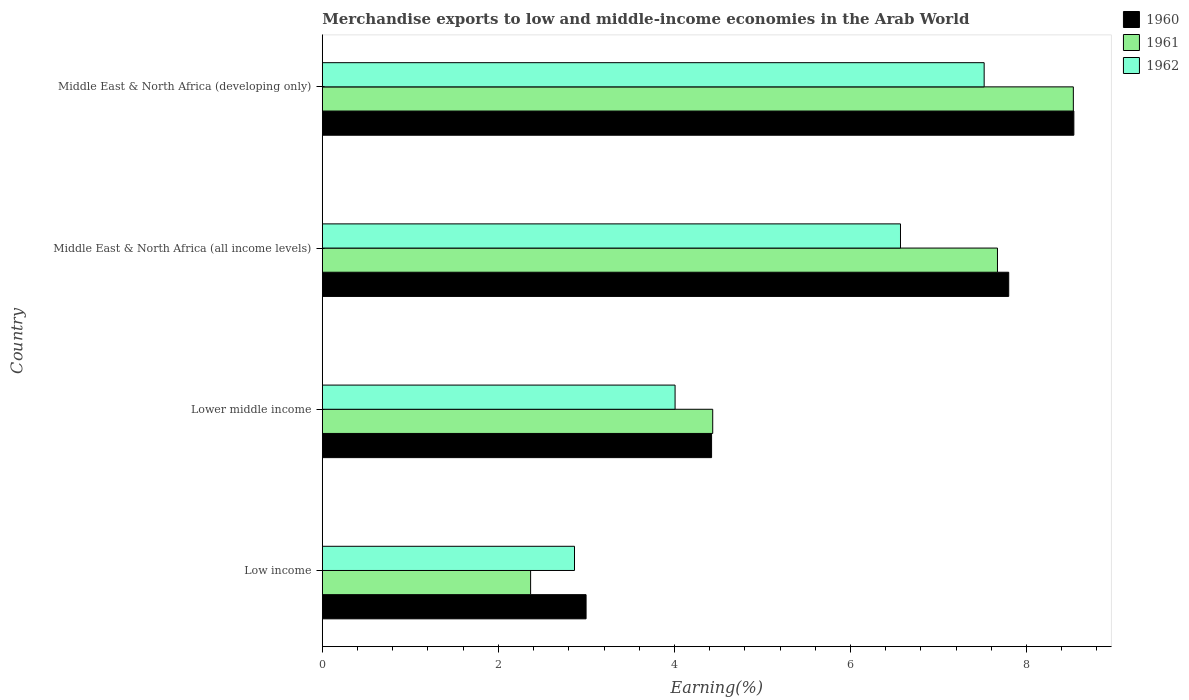Are the number of bars on each tick of the Y-axis equal?
Offer a very short reply. Yes. How many bars are there on the 3rd tick from the top?
Ensure brevity in your answer.  3. How many bars are there on the 1st tick from the bottom?
Provide a succinct answer. 3. What is the label of the 2nd group of bars from the top?
Ensure brevity in your answer.  Middle East & North Africa (all income levels). In how many cases, is the number of bars for a given country not equal to the number of legend labels?
Provide a short and direct response. 0. What is the percentage of amount earned from merchandise exports in 1960 in Low income?
Give a very brief answer. 3. Across all countries, what is the maximum percentage of amount earned from merchandise exports in 1960?
Your answer should be compact. 8.54. Across all countries, what is the minimum percentage of amount earned from merchandise exports in 1962?
Your answer should be very brief. 2.86. In which country was the percentage of amount earned from merchandise exports in 1960 maximum?
Offer a terse response. Middle East & North Africa (developing only). What is the total percentage of amount earned from merchandise exports in 1960 in the graph?
Offer a very short reply. 23.75. What is the difference between the percentage of amount earned from merchandise exports in 1961 in Low income and that in Lower middle income?
Provide a short and direct response. -2.07. What is the difference between the percentage of amount earned from merchandise exports in 1962 in Middle East & North Africa (developing only) and the percentage of amount earned from merchandise exports in 1961 in Low income?
Your answer should be compact. 5.15. What is the average percentage of amount earned from merchandise exports in 1960 per country?
Ensure brevity in your answer.  5.94. What is the difference between the percentage of amount earned from merchandise exports in 1960 and percentage of amount earned from merchandise exports in 1961 in Middle East & North Africa (all income levels)?
Provide a short and direct response. 0.13. In how many countries, is the percentage of amount earned from merchandise exports in 1960 greater than 3.6 %?
Offer a very short reply. 3. What is the ratio of the percentage of amount earned from merchandise exports in 1961 in Lower middle income to that in Middle East & North Africa (all income levels)?
Give a very brief answer. 0.58. What is the difference between the highest and the second highest percentage of amount earned from merchandise exports in 1962?
Your response must be concise. 0.95. What is the difference between the highest and the lowest percentage of amount earned from merchandise exports in 1961?
Make the answer very short. 6.17. Is the sum of the percentage of amount earned from merchandise exports in 1960 in Low income and Lower middle income greater than the maximum percentage of amount earned from merchandise exports in 1962 across all countries?
Your answer should be very brief. No. What does the 1st bar from the bottom in Middle East & North Africa (all income levels) represents?
Ensure brevity in your answer.  1960. How many bars are there?
Your answer should be very brief. 12. Are the values on the major ticks of X-axis written in scientific E-notation?
Provide a succinct answer. No. How many legend labels are there?
Your answer should be very brief. 3. How are the legend labels stacked?
Your answer should be compact. Vertical. What is the title of the graph?
Your response must be concise. Merchandise exports to low and middle-income economies in the Arab World. Does "1974" appear as one of the legend labels in the graph?
Your answer should be very brief. No. What is the label or title of the X-axis?
Your answer should be very brief. Earning(%). What is the Earning(%) in 1960 in Low income?
Your answer should be very brief. 3. What is the Earning(%) of 1961 in Low income?
Provide a succinct answer. 2.37. What is the Earning(%) of 1962 in Low income?
Keep it short and to the point. 2.86. What is the Earning(%) in 1960 in Lower middle income?
Your answer should be compact. 4.42. What is the Earning(%) of 1961 in Lower middle income?
Offer a terse response. 4.43. What is the Earning(%) of 1962 in Lower middle income?
Offer a terse response. 4.01. What is the Earning(%) of 1960 in Middle East & North Africa (all income levels)?
Your answer should be compact. 7.8. What is the Earning(%) of 1961 in Middle East & North Africa (all income levels)?
Ensure brevity in your answer.  7.67. What is the Earning(%) in 1962 in Middle East & North Africa (all income levels)?
Your answer should be compact. 6.57. What is the Earning(%) of 1960 in Middle East & North Africa (developing only)?
Your answer should be very brief. 8.54. What is the Earning(%) in 1961 in Middle East & North Africa (developing only)?
Your answer should be compact. 8.53. What is the Earning(%) in 1962 in Middle East & North Africa (developing only)?
Offer a terse response. 7.52. Across all countries, what is the maximum Earning(%) of 1960?
Make the answer very short. 8.54. Across all countries, what is the maximum Earning(%) in 1961?
Offer a very short reply. 8.53. Across all countries, what is the maximum Earning(%) in 1962?
Offer a very short reply. 7.52. Across all countries, what is the minimum Earning(%) in 1960?
Provide a succinct answer. 3. Across all countries, what is the minimum Earning(%) of 1961?
Provide a succinct answer. 2.37. Across all countries, what is the minimum Earning(%) of 1962?
Your answer should be compact. 2.86. What is the total Earning(%) in 1960 in the graph?
Provide a short and direct response. 23.75. What is the total Earning(%) in 1961 in the graph?
Offer a terse response. 23. What is the total Earning(%) of 1962 in the graph?
Offer a terse response. 20.96. What is the difference between the Earning(%) in 1960 in Low income and that in Lower middle income?
Your response must be concise. -1.43. What is the difference between the Earning(%) in 1961 in Low income and that in Lower middle income?
Make the answer very short. -2.07. What is the difference between the Earning(%) in 1962 in Low income and that in Lower middle income?
Your response must be concise. -1.14. What is the difference between the Earning(%) of 1960 in Low income and that in Middle East & North Africa (all income levels)?
Provide a short and direct response. -4.8. What is the difference between the Earning(%) of 1961 in Low income and that in Middle East & North Africa (all income levels)?
Make the answer very short. -5.3. What is the difference between the Earning(%) in 1962 in Low income and that in Middle East & North Africa (all income levels)?
Provide a short and direct response. -3.7. What is the difference between the Earning(%) of 1960 in Low income and that in Middle East & North Africa (developing only)?
Make the answer very short. -5.54. What is the difference between the Earning(%) in 1961 in Low income and that in Middle East & North Africa (developing only)?
Your answer should be compact. -6.17. What is the difference between the Earning(%) in 1962 in Low income and that in Middle East & North Africa (developing only)?
Provide a succinct answer. -4.65. What is the difference between the Earning(%) of 1960 in Lower middle income and that in Middle East & North Africa (all income levels)?
Make the answer very short. -3.38. What is the difference between the Earning(%) in 1961 in Lower middle income and that in Middle East & North Africa (all income levels)?
Your answer should be compact. -3.23. What is the difference between the Earning(%) of 1962 in Lower middle income and that in Middle East & North Africa (all income levels)?
Provide a succinct answer. -2.56. What is the difference between the Earning(%) of 1960 in Lower middle income and that in Middle East & North Africa (developing only)?
Your answer should be compact. -4.12. What is the difference between the Earning(%) of 1961 in Lower middle income and that in Middle East & North Africa (developing only)?
Ensure brevity in your answer.  -4.1. What is the difference between the Earning(%) of 1962 in Lower middle income and that in Middle East & North Africa (developing only)?
Your answer should be very brief. -3.51. What is the difference between the Earning(%) of 1960 in Middle East & North Africa (all income levels) and that in Middle East & North Africa (developing only)?
Give a very brief answer. -0.74. What is the difference between the Earning(%) in 1961 in Middle East & North Africa (all income levels) and that in Middle East & North Africa (developing only)?
Make the answer very short. -0.86. What is the difference between the Earning(%) of 1962 in Middle East & North Africa (all income levels) and that in Middle East & North Africa (developing only)?
Give a very brief answer. -0.95. What is the difference between the Earning(%) in 1960 in Low income and the Earning(%) in 1961 in Lower middle income?
Offer a very short reply. -1.44. What is the difference between the Earning(%) in 1960 in Low income and the Earning(%) in 1962 in Lower middle income?
Your response must be concise. -1.01. What is the difference between the Earning(%) in 1961 in Low income and the Earning(%) in 1962 in Lower middle income?
Give a very brief answer. -1.64. What is the difference between the Earning(%) of 1960 in Low income and the Earning(%) of 1961 in Middle East & North Africa (all income levels)?
Provide a succinct answer. -4.67. What is the difference between the Earning(%) of 1960 in Low income and the Earning(%) of 1962 in Middle East & North Africa (all income levels)?
Make the answer very short. -3.57. What is the difference between the Earning(%) in 1961 in Low income and the Earning(%) in 1962 in Middle East & North Africa (all income levels)?
Ensure brevity in your answer.  -4.2. What is the difference between the Earning(%) in 1960 in Low income and the Earning(%) in 1961 in Middle East & North Africa (developing only)?
Your answer should be very brief. -5.54. What is the difference between the Earning(%) of 1960 in Low income and the Earning(%) of 1962 in Middle East & North Africa (developing only)?
Your answer should be very brief. -4.52. What is the difference between the Earning(%) of 1961 in Low income and the Earning(%) of 1962 in Middle East & North Africa (developing only)?
Your answer should be compact. -5.15. What is the difference between the Earning(%) in 1960 in Lower middle income and the Earning(%) in 1961 in Middle East & North Africa (all income levels)?
Your answer should be compact. -3.25. What is the difference between the Earning(%) in 1960 in Lower middle income and the Earning(%) in 1962 in Middle East & North Africa (all income levels)?
Offer a terse response. -2.15. What is the difference between the Earning(%) of 1961 in Lower middle income and the Earning(%) of 1962 in Middle East & North Africa (all income levels)?
Your response must be concise. -2.13. What is the difference between the Earning(%) in 1960 in Lower middle income and the Earning(%) in 1961 in Middle East & North Africa (developing only)?
Offer a very short reply. -4.11. What is the difference between the Earning(%) of 1960 in Lower middle income and the Earning(%) of 1962 in Middle East & North Africa (developing only)?
Keep it short and to the point. -3.1. What is the difference between the Earning(%) in 1961 in Lower middle income and the Earning(%) in 1962 in Middle East & North Africa (developing only)?
Your response must be concise. -3.08. What is the difference between the Earning(%) in 1960 in Middle East & North Africa (all income levels) and the Earning(%) in 1961 in Middle East & North Africa (developing only)?
Give a very brief answer. -0.73. What is the difference between the Earning(%) in 1960 in Middle East & North Africa (all income levels) and the Earning(%) in 1962 in Middle East & North Africa (developing only)?
Your response must be concise. 0.28. What is the difference between the Earning(%) in 1961 in Middle East & North Africa (all income levels) and the Earning(%) in 1962 in Middle East & North Africa (developing only)?
Provide a succinct answer. 0.15. What is the average Earning(%) of 1960 per country?
Make the answer very short. 5.94. What is the average Earning(%) in 1961 per country?
Provide a succinct answer. 5.75. What is the average Earning(%) in 1962 per country?
Give a very brief answer. 5.24. What is the difference between the Earning(%) of 1960 and Earning(%) of 1961 in Low income?
Provide a short and direct response. 0.63. What is the difference between the Earning(%) of 1960 and Earning(%) of 1962 in Low income?
Offer a very short reply. 0.13. What is the difference between the Earning(%) of 1961 and Earning(%) of 1962 in Low income?
Offer a terse response. -0.5. What is the difference between the Earning(%) of 1960 and Earning(%) of 1961 in Lower middle income?
Provide a short and direct response. -0.01. What is the difference between the Earning(%) of 1960 and Earning(%) of 1962 in Lower middle income?
Provide a short and direct response. 0.41. What is the difference between the Earning(%) of 1961 and Earning(%) of 1962 in Lower middle income?
Your answer should be compact. 0.43. What is the difference between the Earning(%) in 1960 and Earning(%) in 1961 in Middle East & North Africa (all income levels)?
Provide a short and direct response. 0.13. What is the difference between the Earning(%) of 1960 and Earning(%) of 1962 in Middle East & North Africa (all income levels)?
Provide a short and direct response. 1.23. What is the difference between the Earning(%) of 1961 and Earning(%) of 1962 in Middle East & North Africa (all income levels)?
Offer a very short reply. 1.1. What is the difference between the Earning(%) of 1960 and Earning(%) of 1961 in Middle East & North Africa (developing only)?
Make the answer very short. 0.01. What is the difference between the Earning(%) of 1960 and Earning(%) of 1962 in Middle East & North Africa (developing only)?
Provide a short and direct response. 1.02. What is the difference between the Earning(%) in 1961 and Earning(%) in 1962 in Middle East & North Africa (developing only)?
Provide a succinct answer. 1.01. What is the ratio of the Earning(%) in 1960 in Low income to that in Lower middle income?
Give a very brief answer. 0.68. What is the ratio of the Earning(%) in 1961 in Low income to that in Lower middle income?
Give a very brief answer. 0.53. What is the ratio of the Earning(%) in 1962 in Low income to that in Lower middle income?
Your answer should be compact. 0.71. What is the ratio of the Earning(%) in 1960 in Low income to that in Middle East & North Africa (all income levels)?
Provide a succinct answer. 0.38. What is the ratio of the Earning(%) of 1961 in Low income to that in Middle East & North Africa (all income levels)?
Your answer should be very brief. 0.31. What is the ratio of the Earning(%) of 1962 in Low income to that in Middle East & North Africa (all income levels)?
Provide a succinct answer. 0.44. What is the ratio of the Earning(%) in 1960 in Low income to that in Middle East & North Africa (developing only)?
Your answer should be very brief. 0.35. What is the ratio of the Earning(%) in 1961 in Low income to that in Middle East & North Africa (developing only)?
Keep it short and to the point. 0.28. What is the ratio of the Earning(%) in 1962 in Low income to that in Middle East & North Africa (developing only)?
Your answer should be compact. 0.38. What is the ratio of the Earning(%) of 1960 in Lower middle income to that in Middle East & North Africa (all income levels)?
Keep it short and to the point. 0.57. What is the ratio of the Earning(%) in 1961 in Lower middle income to that in Middle East & North Africa (all income levels)?
Provide a short and direct response. 0.58. What is the ratio of the Earning(%) in 1962 in Lower middle income to that in Middle East & North Africa (all income levels)?
Make the answer very short. 0.61. What is the ratio of the Earning(%) in 1960 in Lower middle income to that in Middle East & North Africa (developing only)?
Offer a terse response. 0.52. What is the ratio of the Earning(%) of 1961 in Lower middle income to that in Middle East & North Africa (developing only)?
Ensure brevity in your answer.  0.52. What is the ratio of the Earning(%) of 1962 in Lower middle income to that in Middle East & North Africa (developing only)?
Offer a terse response. 0.53. What is the ratio of the Earning(%) of 1960 in Middle East & North Africa (all income levels) to that in Middle East & North Africa (developing only)?
Your answer should be compact. 0.91. What is the ratio of the Earning(%) of 1961 in Middle East & North Africa (all income levels) to that in Middle East & North Africa (developing only)?
Provide a short and direct response. 0.9. What is the ratio of the Earning(%) of 1962 in Middle East & North Africa (all income levels) to that in Middle East & North Africa (developing only)?
Give a very brief answer. 0.87. What is the difference between the highest and the second highest Earning(%) of 1960?
Your answer should be very brief. 0.74. What is the difference between the highest and the second highest Earning(%) in 1961?
Ensure brevity in your answer.  0.86. What is the difference between the highest and the second highest Earning(%) of 1962?
Provide a succinct answer. 0.95. What is the difference between the highest and the lowest Earning(%) in 1960?
Your answer should be compact. 5.54. What is the difference between the highest and the lowest Earning(%) of 1961?
Your response must be concise. 6.17. What is the difference between the highest and the lowest Earning(%) of 1962?
Provide a succinct answer. 4.65. 